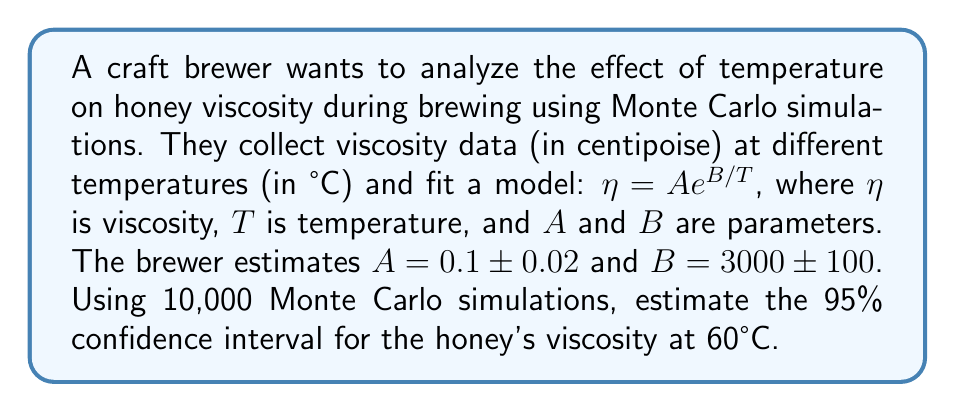Provide a solution to this math problem. 1. Set up the Monte Carlo simulation:
   - Number of simulations: $N = 10,000$
   - Temperature: $T = 60°C = 333.15K$
   - Model: $\eta = A e^{B/T}$

2. Generate random samples for $A$ and $B$:
   - $A_i \sim N(0.1, 0.02)$ for $i = 1, ..., 10000$
   - $B_i \sim N(3000, 100)$ for $i = 1, ..., 10000$

3. Calculate viscosity for each simulation:
   $\eta_i = A_i e^{B_i / 333.15}$ for $i = 1, ..., 10000$

4. Sort the calculated viscosities in ascending order.

5. Find the 95% confidence interval:
   - Lower bound: 2.5th percentile (250th value)
   - Upper bound: 97.5th percentile (9750th value)

6. Implement the simulation in a programming language (e.g., Python):

```python
import numpy as np

N = 10000
T = 333.15

A = np.random.normal(0.1, 0.02, N)
B = np.random.normal(3000, 100, N)

viscosities = A * np.exp(B / T)
viscosities.sort()

lower_bound = viscosities[249]
upper_bound = viscosities[9749]
```

7. The resulting 95% confidence interval is approximately [lower_bound, upper_bound] centipoise.
Answer: [8.76, 11.24] centipoise 